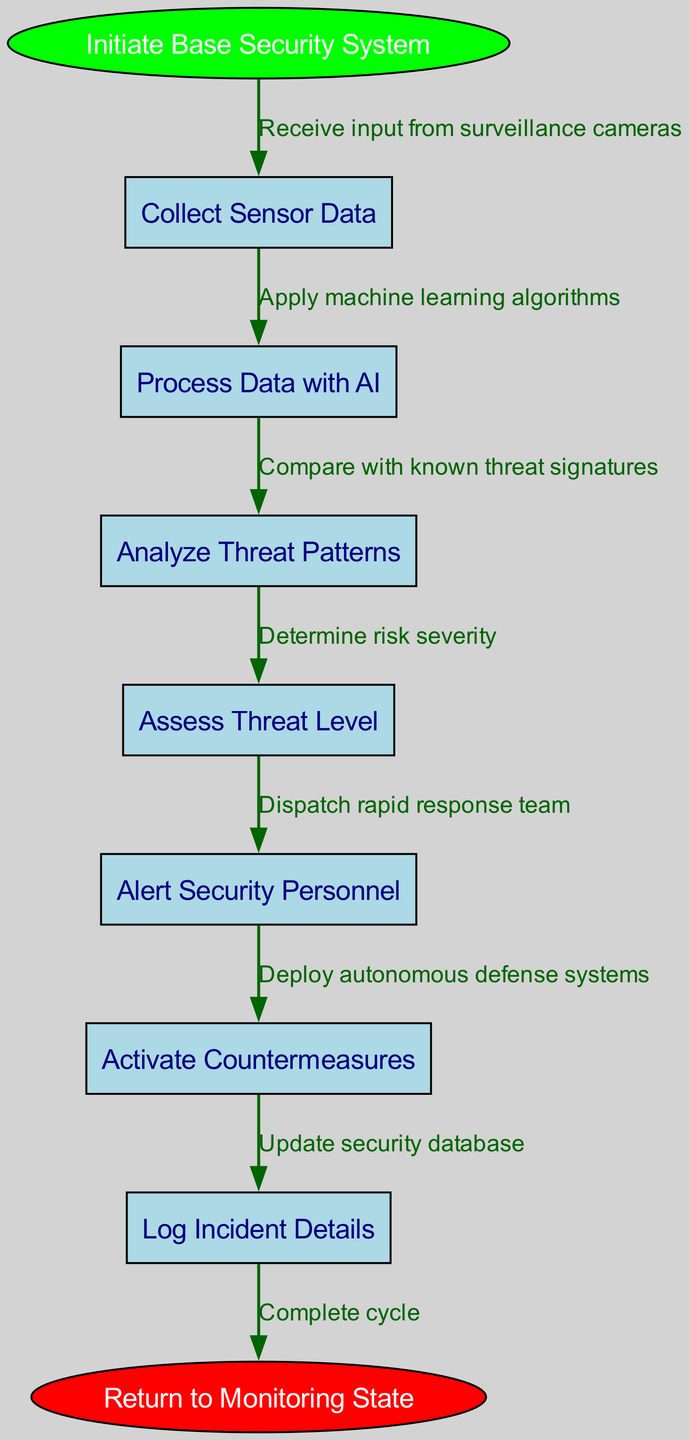What is the start node of the flow chart? The start node is labeled "Initiate Base Security System." This is directly stated at the beginning of the flow chart.
Answer: Initiate Base Security System How many nodes are there in total? There are seven nodes in total: one start node, six intermediate nodes, and one end node. This can be counted directly from the diagram.
Answer: Seven What is the end node of the flow chart? The end node is labeled "Return to Monitoring State." This is explicitly stated at the end of the flow chart.
Answer: Return to Monitoring State Which node follows "Process Data with AI"? The node that follows "Process Data with AI" is "Analyze Threat Patterns." This can be identified by examining the flow from the previous node.
Answer: Analyze Threat Patterns What type of algorithms is applied in the step "Process Data with AI"? The step states "Apply machine learning algorithms," referring specifically to the type of technology utilized in the data processing.
Answer: Machine learning What is the edge connecting "Assess Threat Level" to its preceding node? The edge connecting "Assess Threat Level" to "Analyze Threat Patterns" is labeled "Determine risk severity," indicating the relationship and flow direction.
Answer: Determine risk severity If a threat is detected, which node is activated immediately afterward? The node that is activated immediately after detecting a threat is "Alert Security Personnel." This can be tracked through the flow of the process.
Answer: Alert Security Personnel Which node is the final step before the system returns to monitoring? The final step before returning to monitoring is "Log Incident Details." This is the last intermediate step connected to the end node.
Answer: Log Incident Details What action is taken as a countermeasure when a threat level is assessed? The action taken is "Activate Countermeasures," highlighting the system’s response to threats based on assessment.
Answer: Activate Countermeasures 